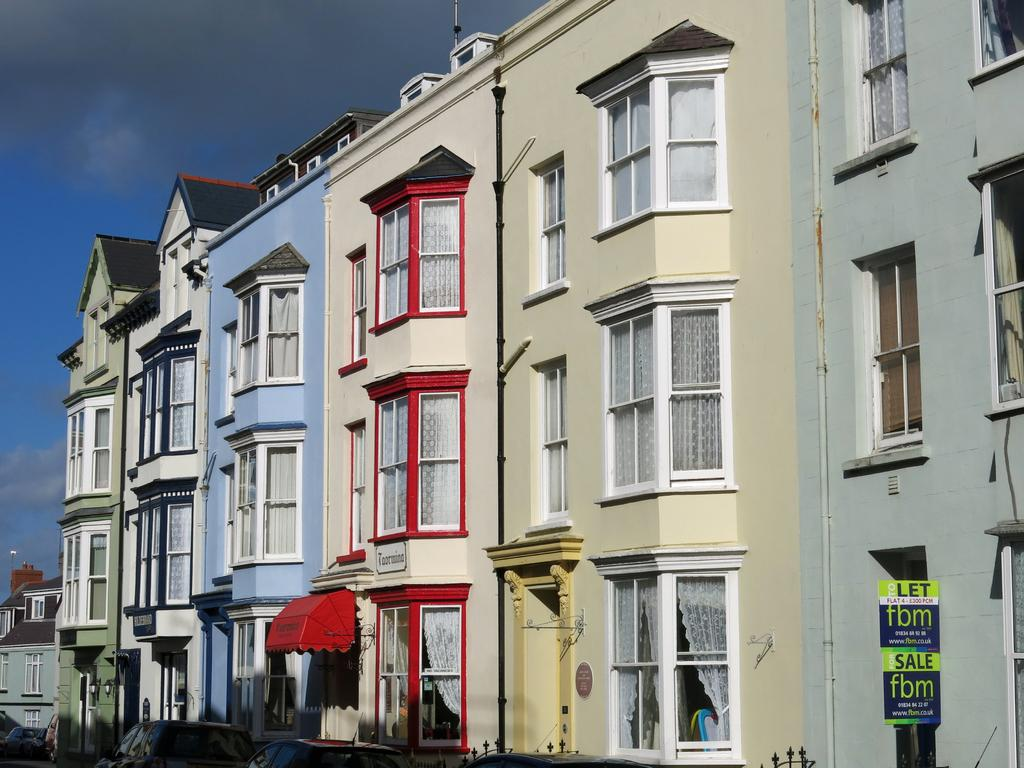What type of structures can be seen in the image? There are buildings in the image. What feature is present in the buildings? There are glass windows in the image. What else can be seen on the surface in the image? There are vehicles visible on the surface in the image. What is visible in the sky in the image? Clouds are present in the sky in the image. Where is the toy located in the image? There is no toy present in the image. How much sugar is visible in the image? There is no sugar visible in the image. 